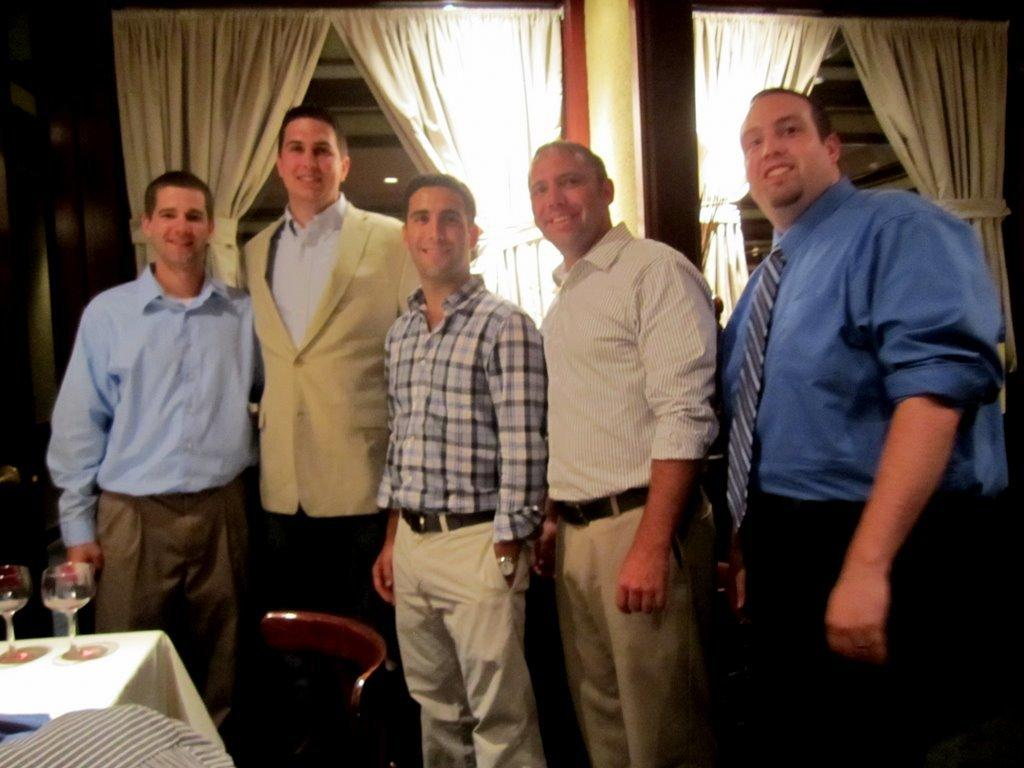How many people are the people are in the image? There are five people in the image. What are the people doing in the image? The people are standing and laughing. What objects are on the table in front of the people? There are glasses on a table in front of the people. What type of window treatment is visible in the image? There are curtains visible in the image. What type of drink is the kitten enjoying in the image? There is no kitten present in the image, and therefore no such activity can be observed. 